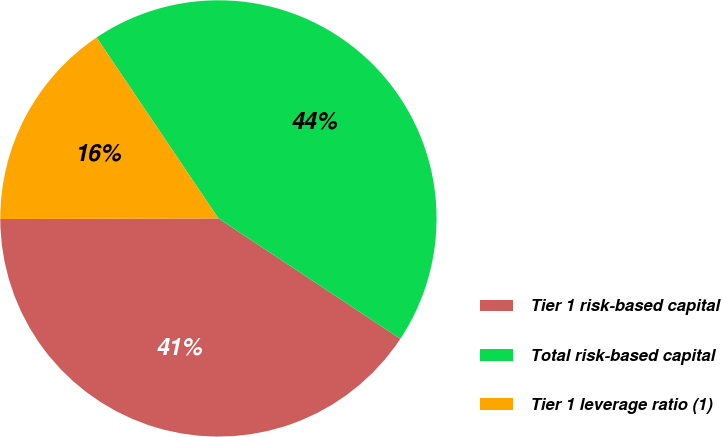Convert chart. <chart><loc_0><loc_0><loc_500><loc_500><pie_chart><fcel>Tier 1 risk-based capital<fcel>Total risk-based capital<fcel>Tier 1 leverage ratio (1)<nl><fcel>40.66%<fcel>43.74%<fcel>15.61%<nl></chart> 